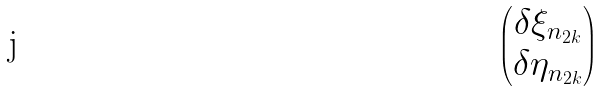<formula> <loc_0><loc_0><loc_500><loc_500>\begin{pmatrix} \delta \xi _ { n _ { 2 k } } \\ \delta \eta _ { n _ { 2 k } } \end{pmatrix}</formula> 